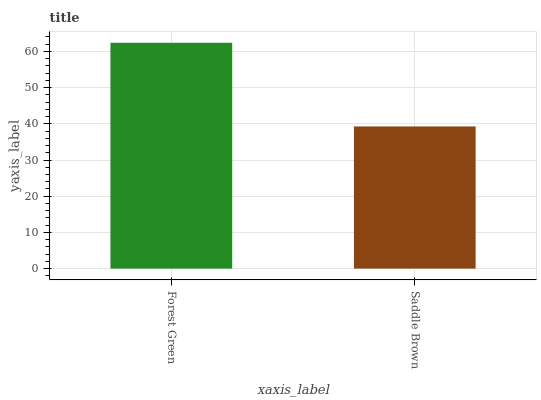Is Saddle Brown the minimum?
Answer yes or no. Yes. Is Forest Green the maximum?
Answer yes or no. Yes. Is Saddle Brown the maximum?
Answer yes or no. No. Is Forest Green greater than Saddle Brown?
Answer yes or no. Yes. Is Saddle Brown less than Forest Green?
Answer yes or no. Yes. Is Saddle Brown greater than Forest Green?
Answer yes or no. No. Is Forest Green less than Saddle Brown?
Answer yes or no. No. Is Forest Green the high median?
Answer yes or no. Yes. Is Saddle Brown the low median?
Answer yes or no. Yes. Is Saddle Brown the high median?
Answer yes or no. No. Is Forest Green the low median?
Answer yes or no. No. 